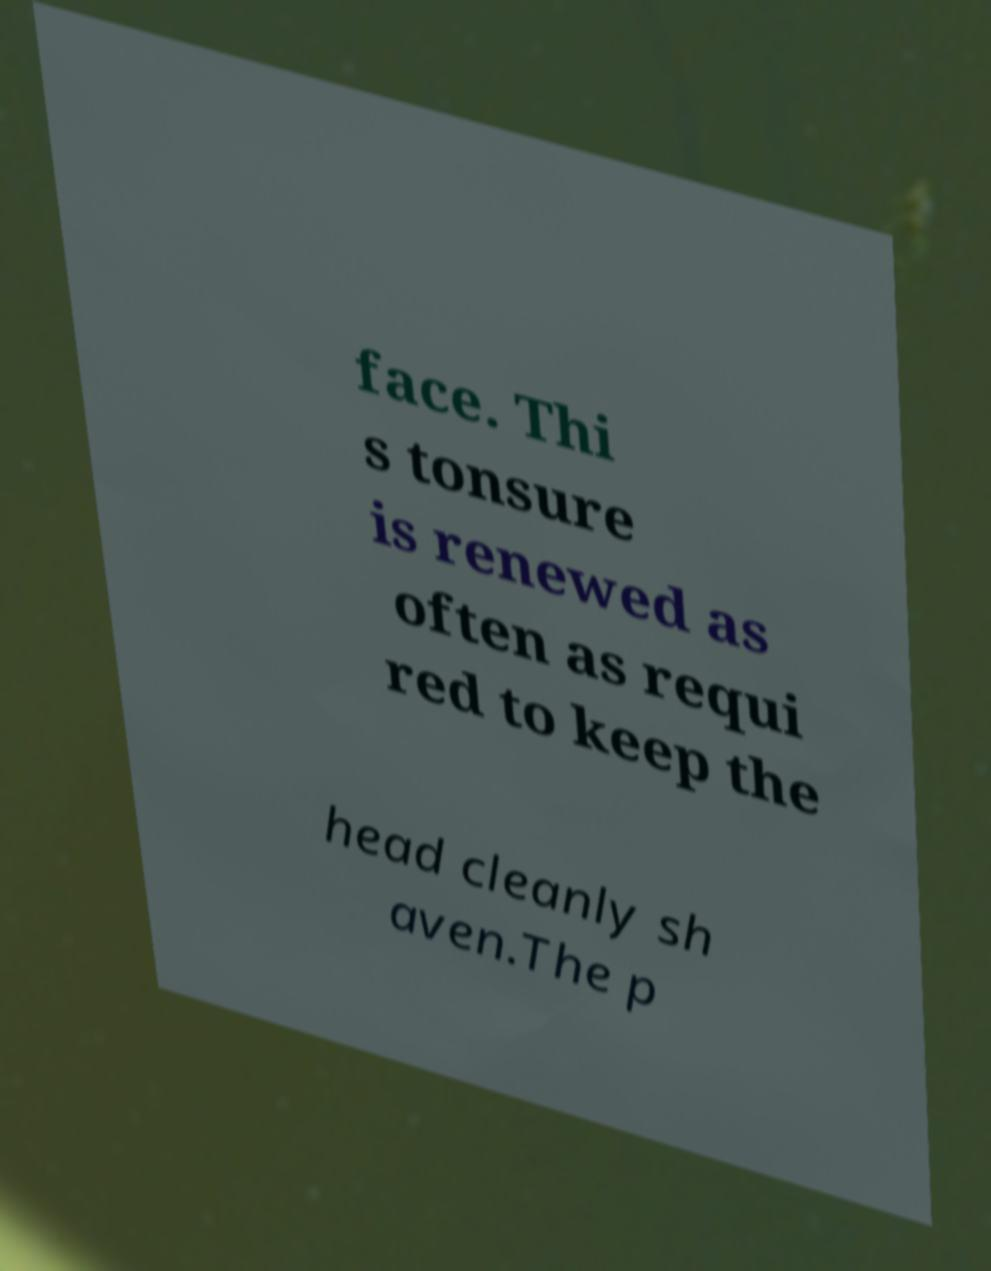Please read and relay the text visible in this image. What does it say? face. Thi s tonsure is renewed as often as requi red to keep the head cleanly sh aven.The p 